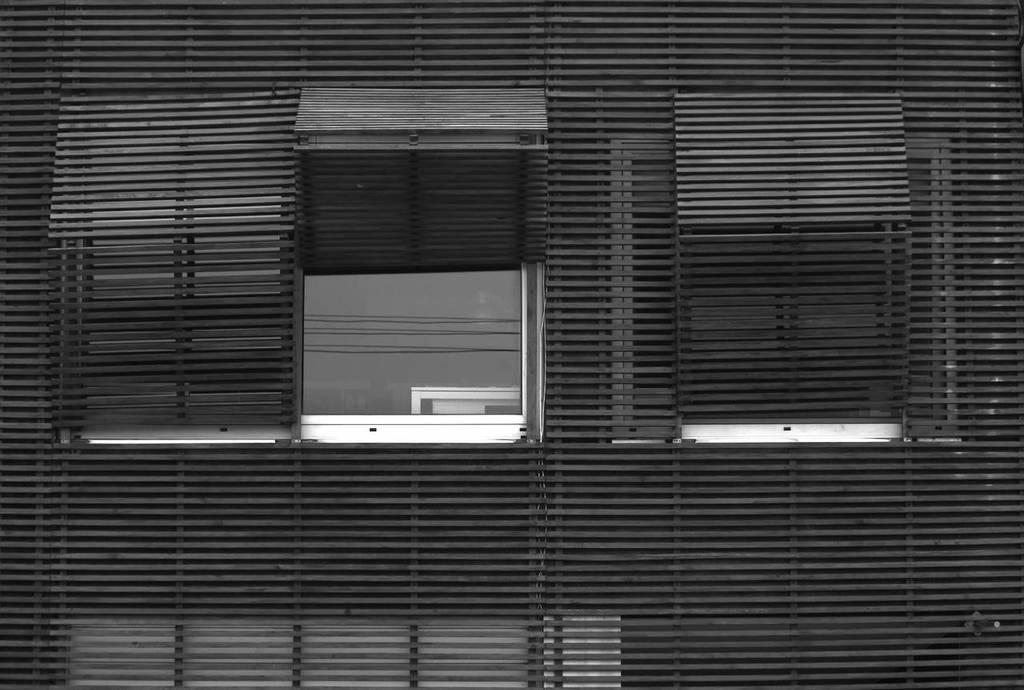What is present near a window in the image? There is a blind to a window in the image. What is the state of one of the blinds in the image? One of the blinds is opened in the image. What type of birthday celebration is happening in the image? There is no birthday celebration present in the image; it only features a blind to a window. What is the nose of the person in the image doing? There is no person present in the image, so there is no nose to describe. 